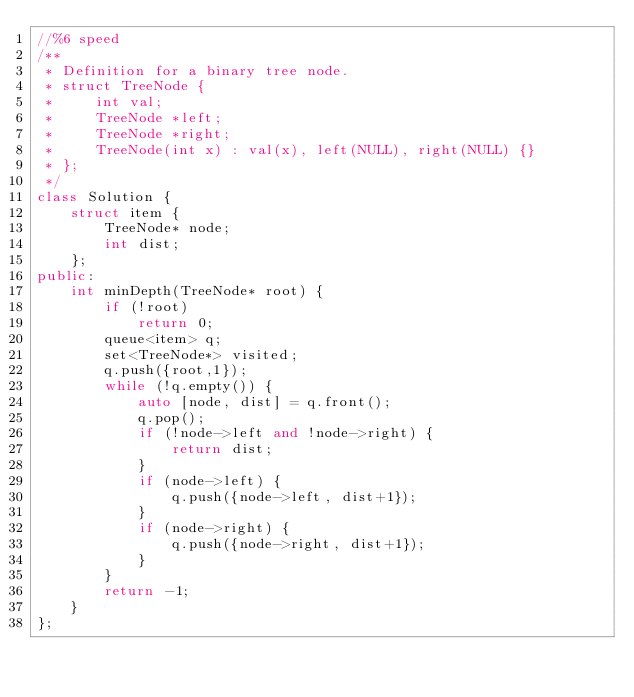<code> <loc_0><loc_0><loc_500><loc_500><_C++_>//%6 speed
/**
 * Definition for a binary tree node.
 * struct TreeNode {
 *     int val;
 *     TreeNode *left;
 *     TreeNode *right;
 *     TreeNode(int x) : val(x), left(NULL), right(NULL) {}
 * };
 */
class Solution {
    struct item {
        TreeNode* node;
        int dist;
    };
public:
    int minDepth(TreeNode* root) {
        if (!root)
            return 0;
        queue<item> q;
        set<TreeNode*> visited;
        q.push({root,1});
        while (!q.empty()) {
            auto [node, dist] = q.front();
            q.pop();
            if (!node->left and !node->right) {
                return dist;
            }
            if (node->left) {
                q.push({node->left, dist+1});
            }
            if (node->right) {
                q.push({node->right, dist+1});
            }
        }
        return -1;
    }
};
</code> 